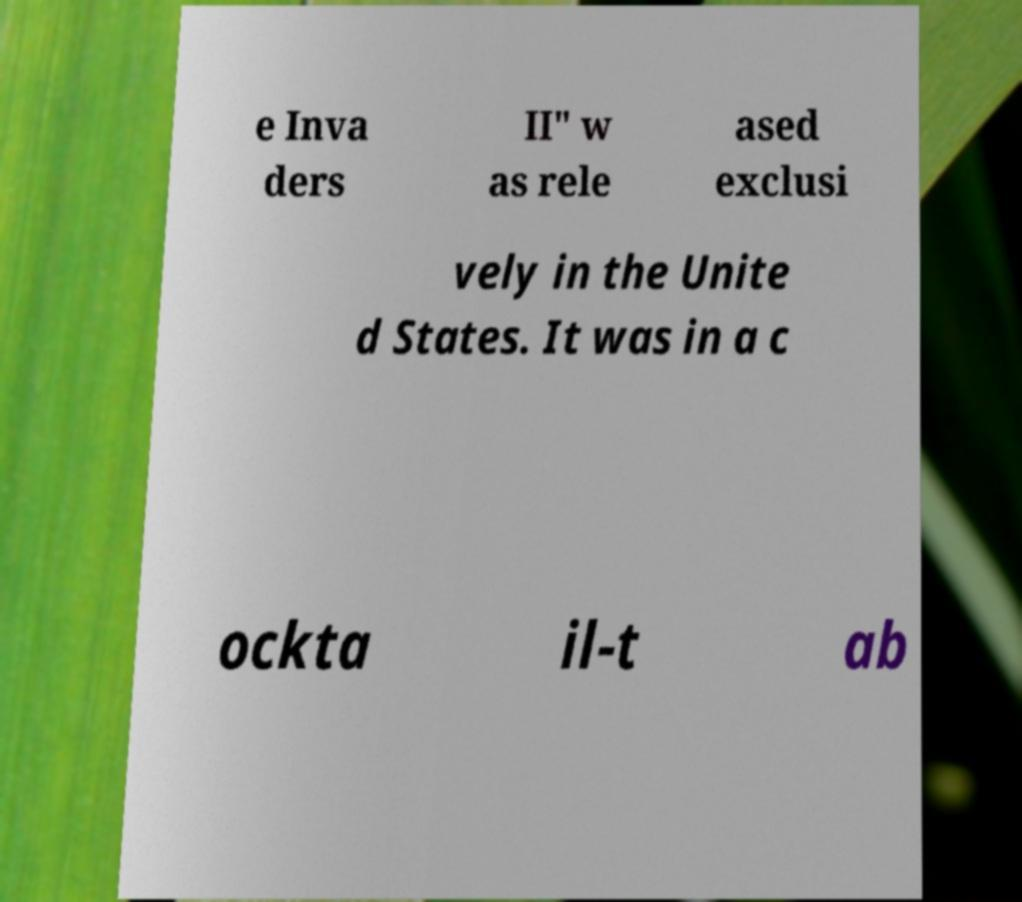Can you read and provide the text displayed in the image?This photo seems to have some interesting text. Can you extract and type it out for me? e Inva ders II" w as rele ased exclusi vely in the Unite d States. It was in a c ockta il-t ab 